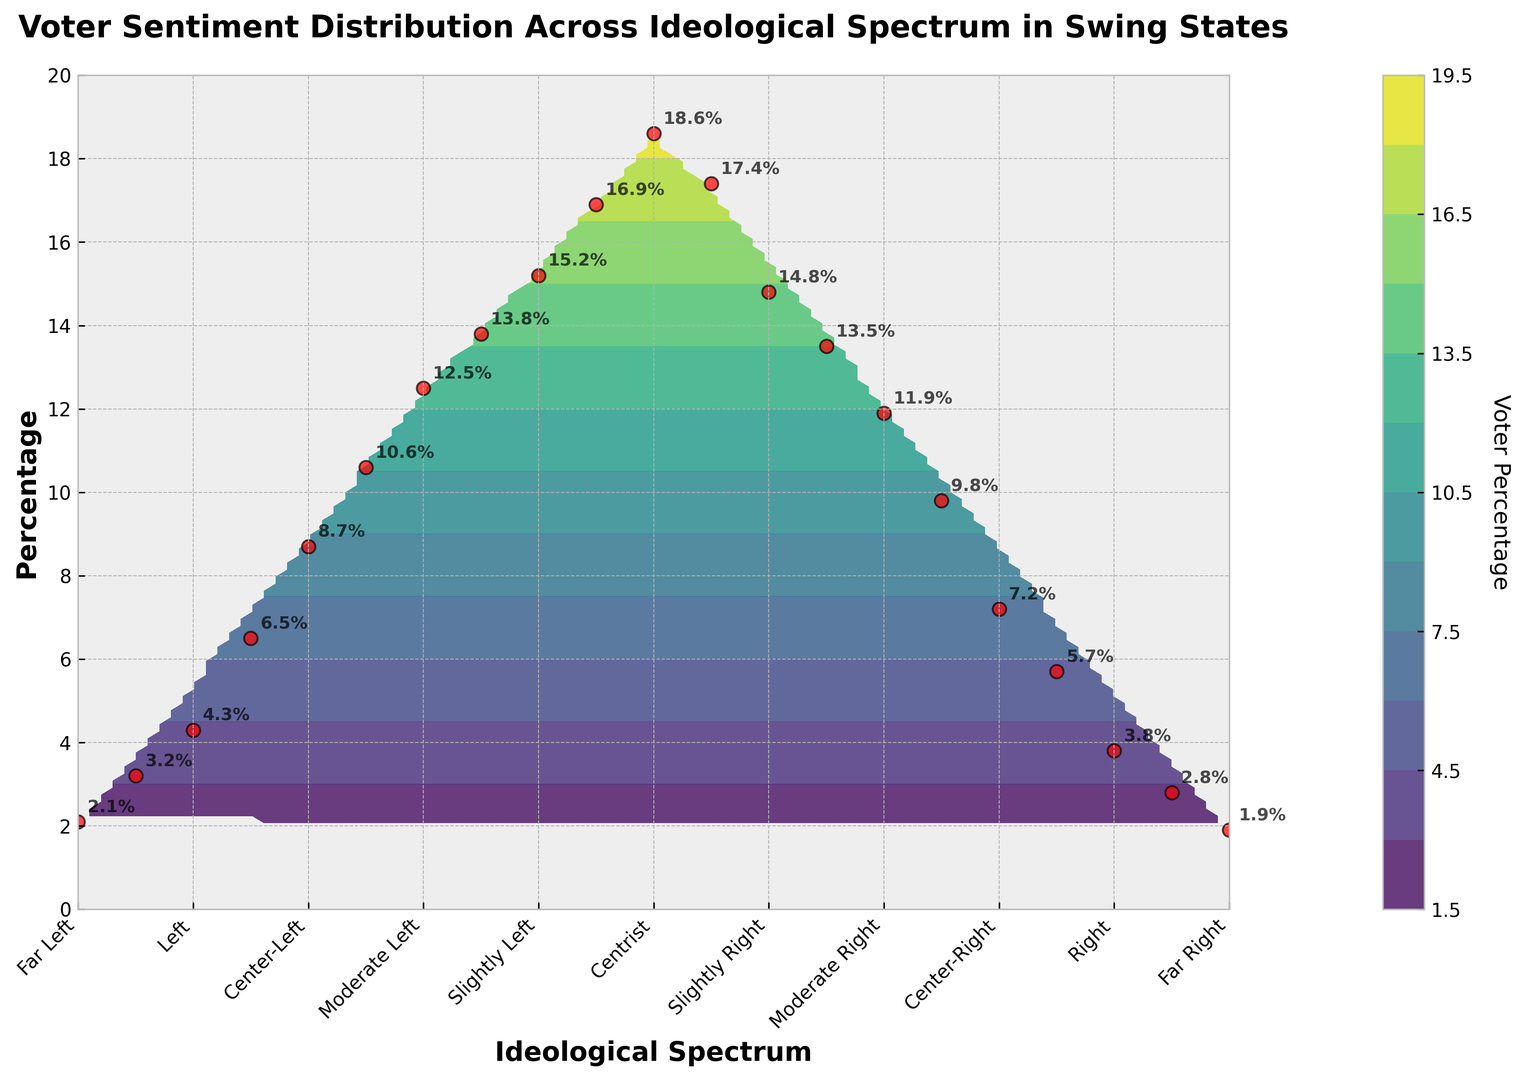what is the ideological range where voter sentiment is highest? By looking at the plotted points, find the ideology near where the height of the red scatter marks (which represents percentage) is tallest.
Answer: Centrist (-0.5 to 0.5) Which ideological range has the lowest voter sentiment? Check for the lowest plotted percentage points along the ideological spectrum.
Answer: Far Left (-5) and Far Right (5) Is voter sentiment higher on the left or right side of the spectrum? Compare the heights of red scatter marks (percentage) on the left (negative) side against those on the right (positive) side of the spectrum.
Answer: Left What is the percentage difference between the peak sentiment and the far-left sentiment? Find the peak sentiment percentage and the far-left percentage, then subtract the latter from the former. Peak sentiment: 18.6%, Far-left: 2.1%. Calculation: 18.6 - 2.1 = 16.5
Answer: 16.5% Which has a higher sentiment: Moderate Right (2) or Slightly Left (-1)? Compare the heights of the red scatter marks at ideology 2 and -1.
Answer: Slightly Left (-1) How does voter sentiment change as you move from Moderate Left (-2) to Moderate Right (2)? Analyze the trend in the heights of the scatter marks from -2 to 2. Notice the changes in percentage shown along that range.
Answer: Decreases At which ideological position does the sentiment noticeably drop from the previous level? Observe the scatter plots and detect a significant drop in height percentage from one ideological point to the next.
Answer: From Slightly Right (1.5) to Moderate Right (2.5) What's the combined percentage of voters in the Centrist, Slightly Left and Slightly Right categories? Sum up the percentages for Centrist (18.6%), Slightly Left (15.2%) and Slightly Right (14.8%). Calculation: 18.6 + 15.2 + 14.8 = 48.6
Answer: 48.6% Which ideological sentiment is more spread out, Slightly Left (-1) or Slightly Right (1)? Check the clustering of sentiment data points around ideologies -1 and 1.
Answer: Slightly Left (-1) Is there a noticeable clustering of voter sentiment near the center of the ideological spectrum? Look for areas with numerous close-together red scatter marks, indicating concentrated data points.
Answer: Yes 